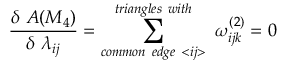Convert formula to latex. <formula><loc_0><loc_0><loc_500><loc_500>\frac { \delta A ( M _ { 4 } ) } { \delta \lambda _ { i j } } = \sum _ { c o m m o n e d g e < i j > } ^ { t r i a n g l e s w i t h } \omega _ { i j k } ^ { ( 2 ) } = 0</formula> 